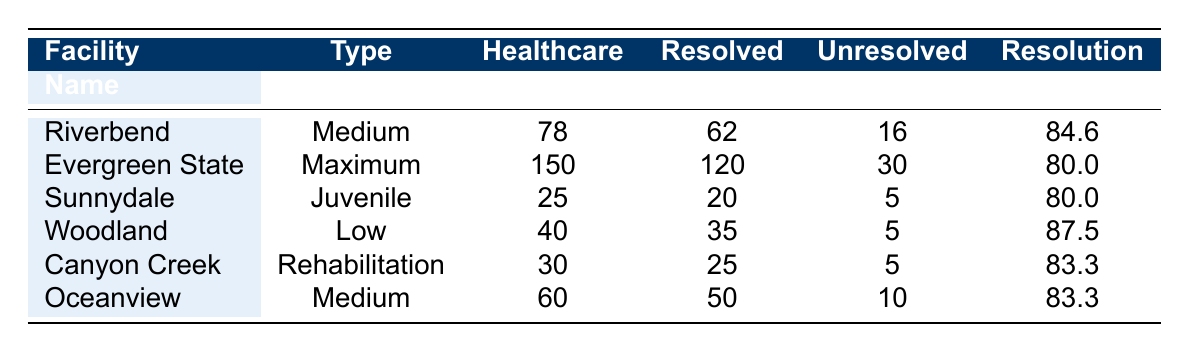What is the total number of healthcare-related grievances at Riverbend Correctional Institution? The table shows that Riverbend Correctional Institution has 78 healthcare-related grievances.
Answer: 78 What is the resolution rate for Evergreen State Penitentiary? According to the table, Evergreen State Penitentiary has a resolution rate of 80.0%.
Answer: 80.0% How many unresolved grievances are there at Canyon Creek Treatment Center? The table lists 5 unresolved grievances for Canyon Creek Treatment Center.
Answer: 5 Which facility type has the highest resolution rate? Comparing the resolution rates of all facility types, Woodland Correctional Facility has the highest rate at 87.5%.
Answer: Low Security How many healthcare-related grievances at Oceanview Correctional Institution were resolved? The table indicates that 50 grievances were resolved at Oceanview Correctional Institution.
Answer: 50 What is the total number of grievances at Sunnydale Detention Center? The total number of grievances at Sunnydale Detention Center is 45, as shown in the table.
Answer: 45 How many more healthcare-related grievances does Evergreen State Penitentiary have compared to Woodland Correctional Facility? Evergreen State Penitentiary has 150 healthcare-related grievances, while Woodland Correctional Facility has 40. The difference is 150 - 40 = 110.
Answer: 110 Is the number of unresolved grievances at Oceanview Correctional Institution greater than that at Canyon Creek Treatment Center? Oceanview has 10 unresolved grievances, while Canyon Creek has 5. Therefore, the statement is true.
Answer: Yes What percentage of healthcare-related grievances at Riverbend Correctional Institution were resolved? To find this percentage, divide the resolved grievances (32) by the healthcare-related grievances (78) and multiply by 100: (32/78) * 100 = approximately 41.0%.
Answer: 41.0% What is the average resolution rate across all facilities? Calculate the sum of the resolution rates: 84.6 + 80.0 + 80.0 + 87.5 + 83.3 + 83.3 = 498.7. Then divide by the number of facilities (6): 498.7 / 6 = 83.1 (rounded to one decimal).
Answer: 83.1 What facility has the lowest number of healthcare-related grievances? The facility with the lowest number of healthcare-related grievances is Sunnydale Detention Center with 25 grievances.
Answer: Sunnydale Detention Center 